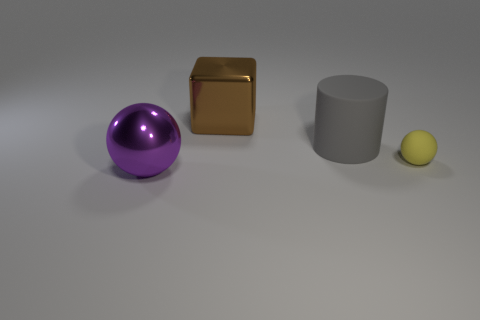Add 1 big brown metal cubes. How many objects exist? 5 Subtract all blocks. How many objects are left? 3 Subtract all gray matte cylinders. Subtract all tiny red shiny spheres. How many objects are left? 3 Add 1 large cubes. How many large cubes are left? 2 Add 3 big matte things. How many big matte things exist? 4 Subtract 0 blue cylinders. How many objects are left? 4 